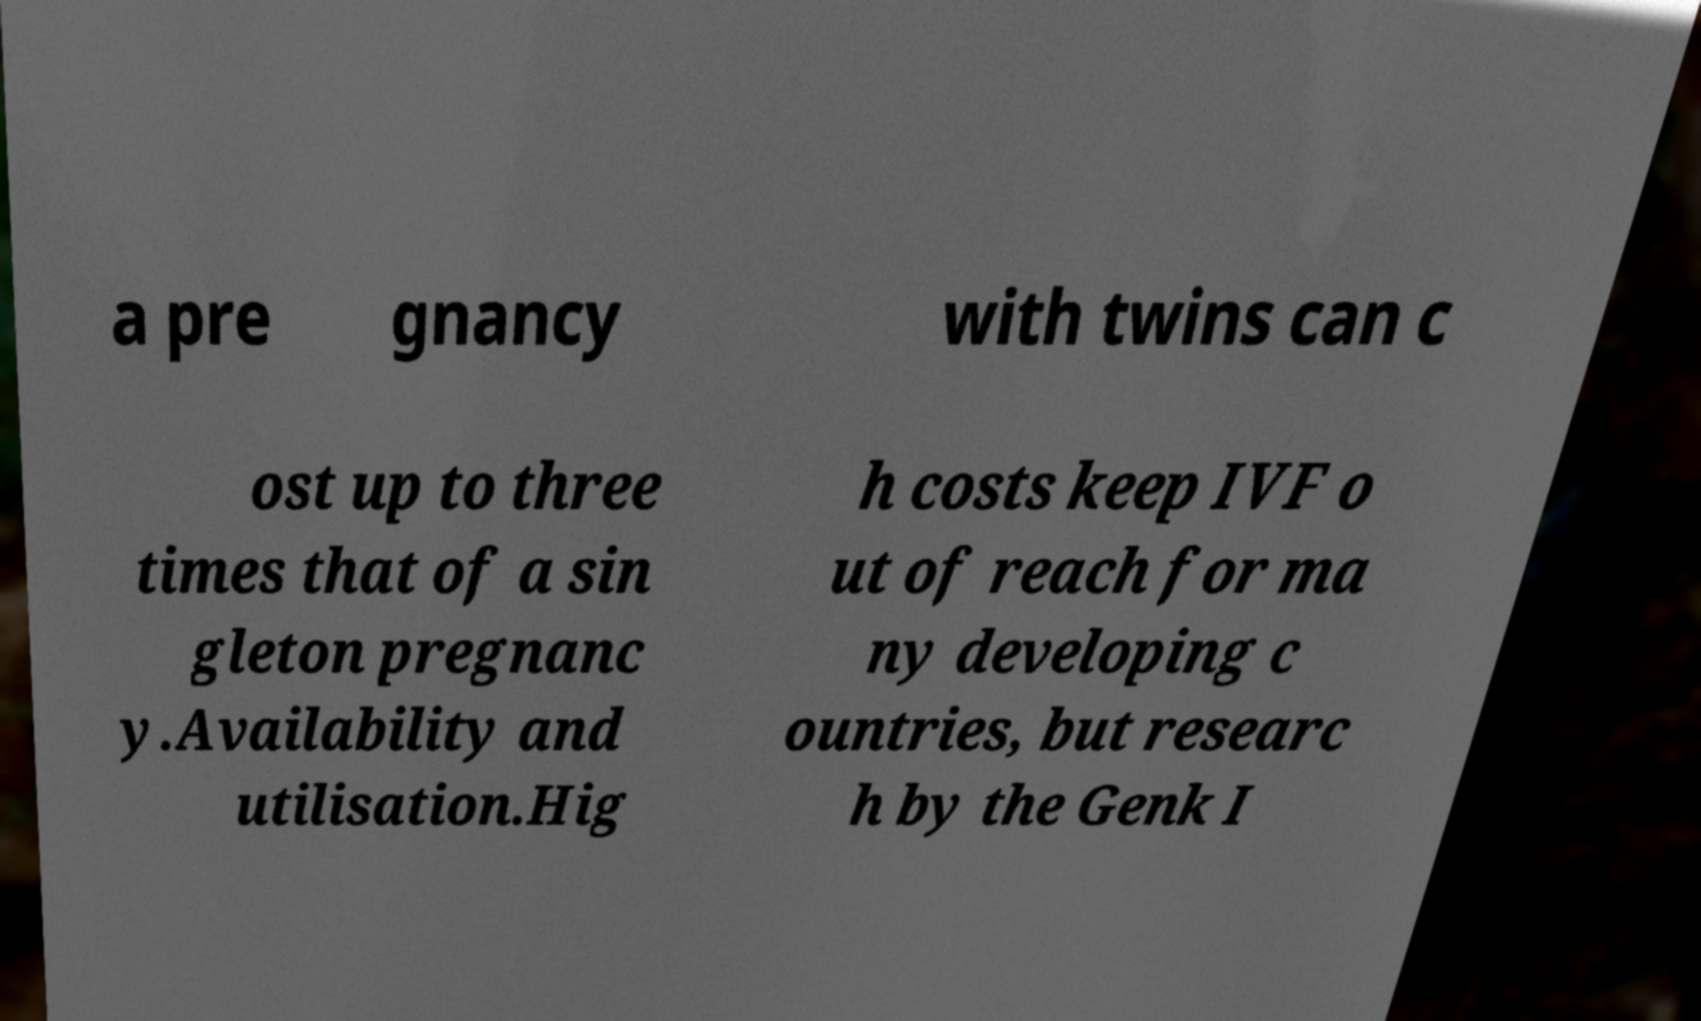Please read and relay the text visible in this image. What does it say? a pre gnancy with twins can c ost up to three times that of a sin gleton pregnanc y.Availability and utilisation.Hig h costs keep IVF o ut of reach for ma ny developing c ountries, but researc h by the Genk I 